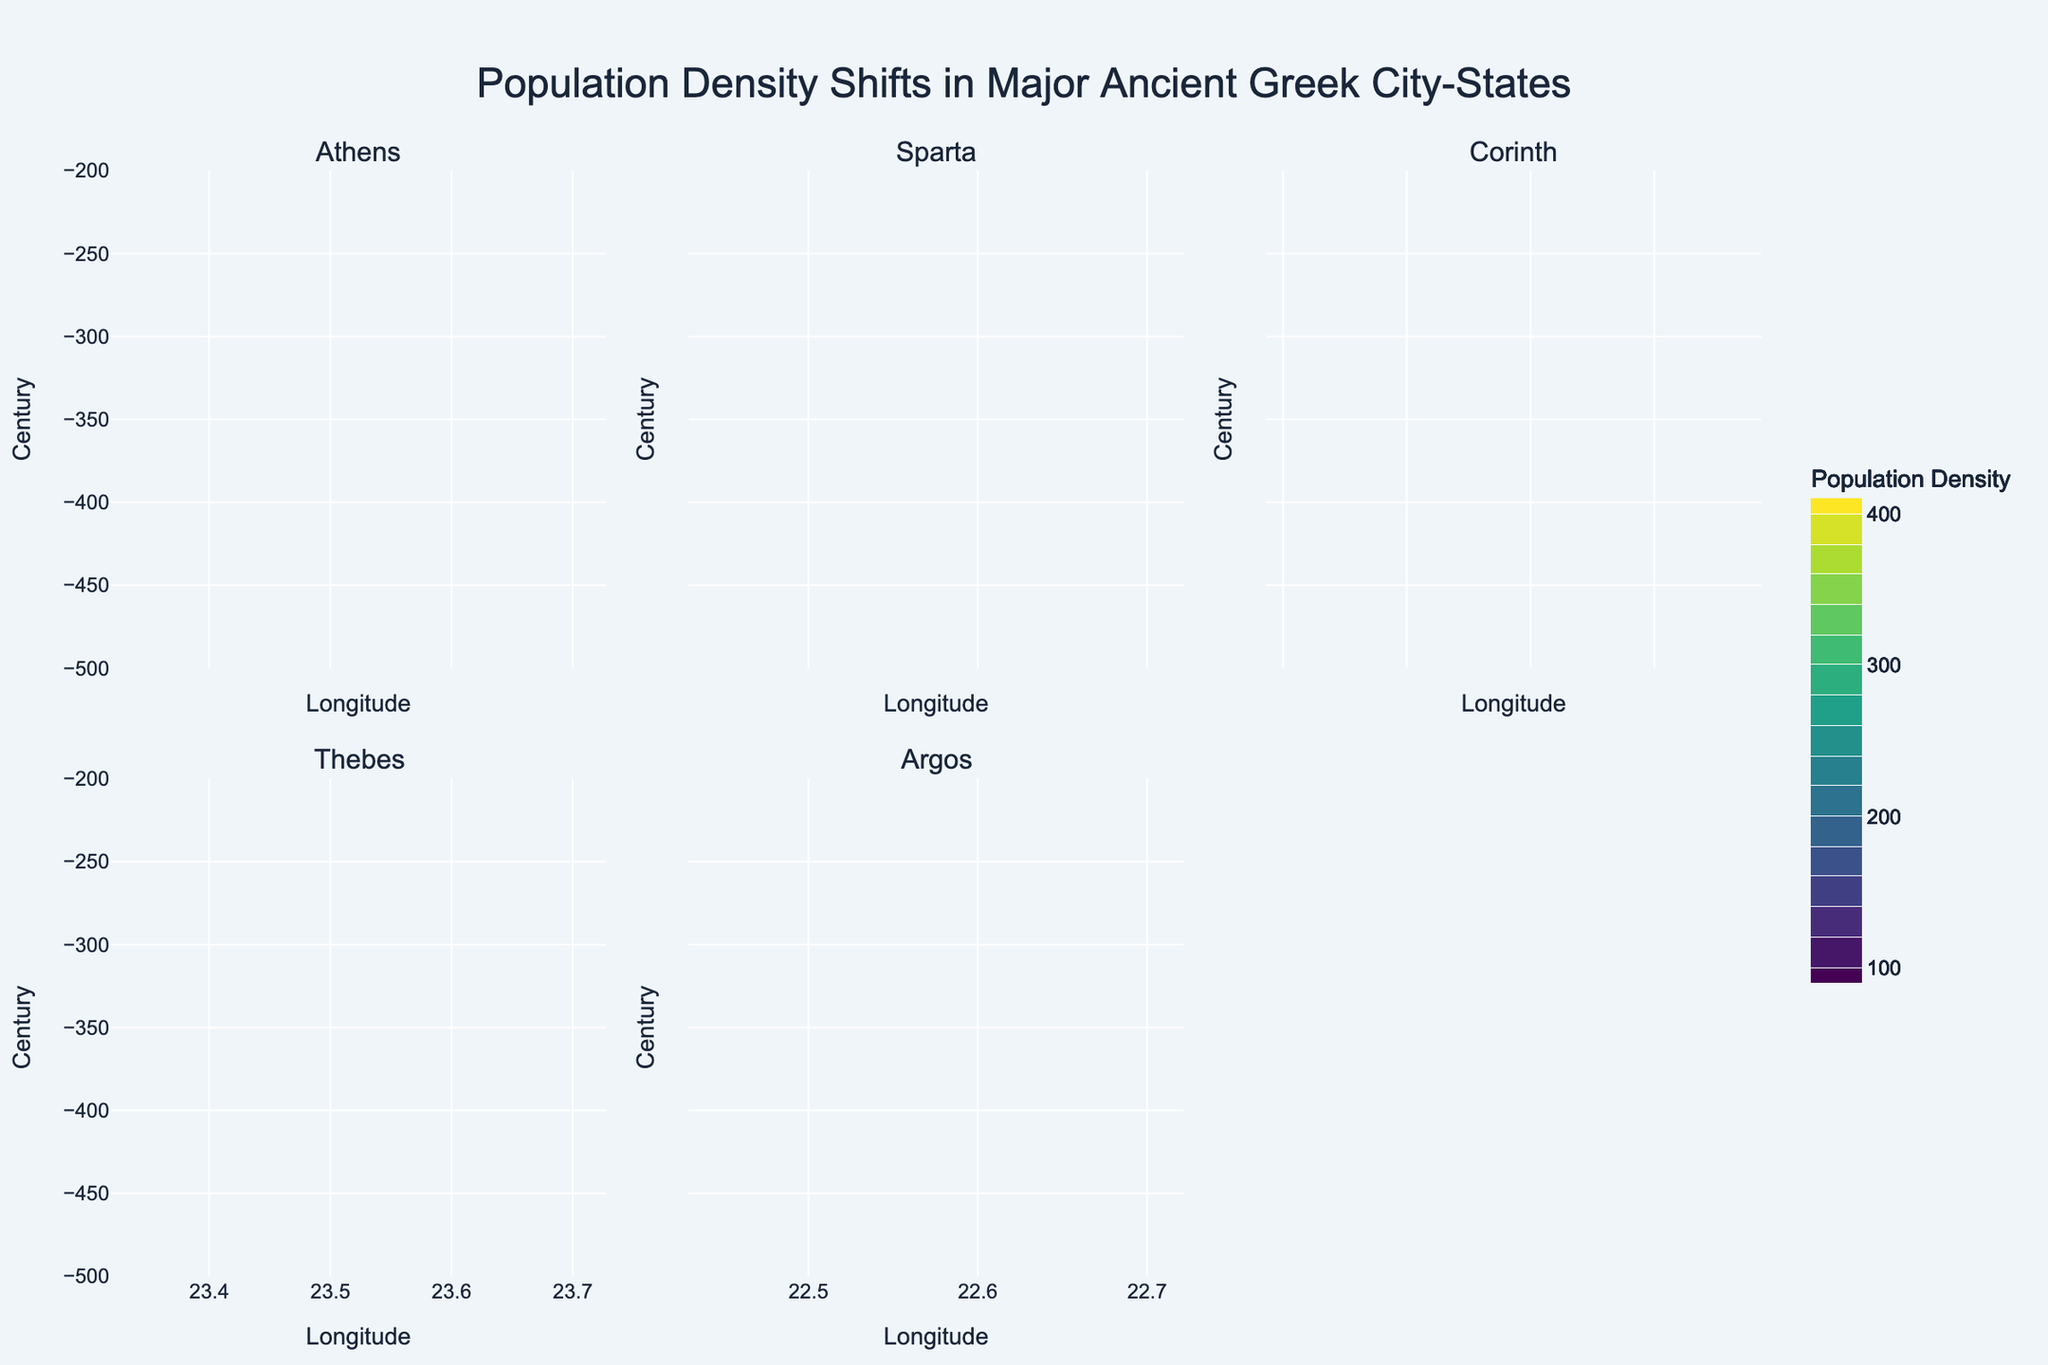What's the title of the figure? The title of the figure is given at the top of the chart.
Answer: "Population Density Shifts in Major Ancient Greek City-States" Which city-state is represented in the subplot at the top left? The top left subplot title indicates the name of the city-state.
Answer: Athens How did the population density of Athens change from -400 to -300? By looking at the contour lines within Athens' subplot, you can see the population density decreased from 350 to 320.
Answer: It decreased by 30 Which city-state had the highest population density in the century -500? Refer to the contour levels at century -500 across all subplots. Athens shows the highest density of 300.
Answer: Athens Compare the population density trend of Sparta and Argos from -500 to -200. Which city experienced a greater decrease? By observing the contour lines for both Sparta and Argos from -500 to -200, Sparta's density decreases from 150 to 130, while Argos decreases from 180 to 170. Sparta's decrease is 20, while Argos decreases by 10.
Answer: Sparta experienced a greater decrease Which city-state shows the least variation in population density over the entire period? Check the contour lines for each city-state for overall consistency. Thebes' subplot appears to have the least variation with densities ranging between 200 and 220.
Answer: Thebes From which longitude does the contour plot of Corinth show data? The subplot for Corinth indicates precise longitude.
Answer: 22.9321 What is the population density of Thebes in the century -300? By checking Thebes' subplot at -300, the population density value can be read directly off the contour.
Answer: 210 Does any city-state have a population density of 240 in -200 century? Examine the contour lines for all subplots at century -200 to find any contour marked as 240.
Answer: Corinth How would you describe the general trend of population density in Athens over time? Analyze the contour lines in Athens' subplot. The density increases to a peak at -400 and gradually decreases afterwards.
Answer: Initial increase and then gradual decrease 